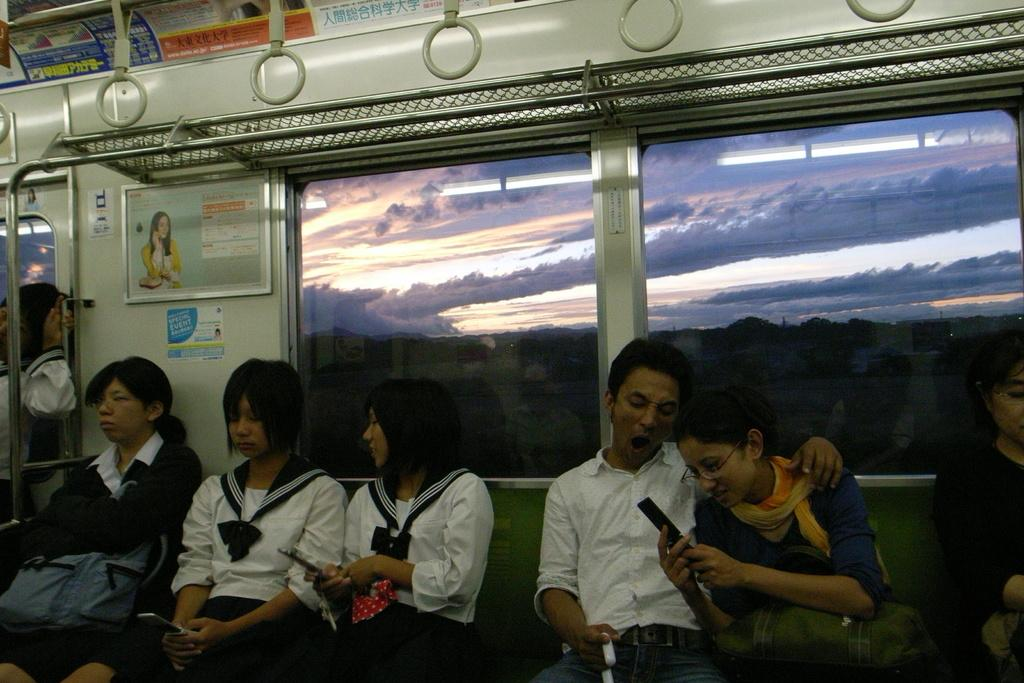What type of view is shown in the image? A: The image shows the internal view of a vehicle. What feature allows passengers to see outside the vehicle? There are glass windows in the vehicle. What decorative items can be seen inside the vehicle? There are posters and holders visible in the vehicle. What can be seen outside the vehicle through the windows? Trees and the sky with clouds are visible outside the vehicle. What type of bell can be heard ringing outside the vehicle in the image? There is no bell present or ringing in the image; it only shows the internal view of the vehicle. What kind of stone is visible on the dashboard of the vehicle in the image? There is no stone visible on the dashboard or anywhere else in the vehicle in the image. 